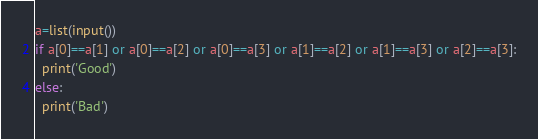Convert code to text. <code><loc_0><loc_0><loc_500><loc_500><_Python_>a=list(input())
if a[0]==a[1] or a[0]==a[2] or a[0]==a[3] or a[1]==a[2] or a[1]==a[3] or a[2]==a[3]:
  print('Good')
else:
  print('Bad')
</code> 